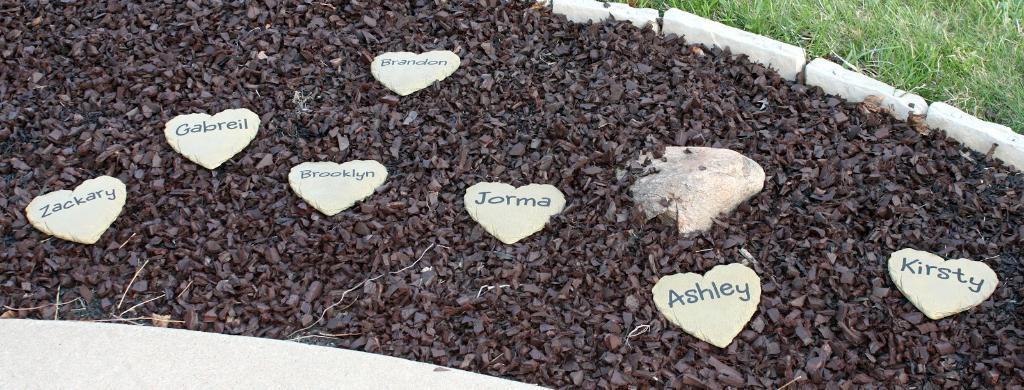What type of vegetation is present in the image? There is grass in the image. What other objects can be seen in the image besides the grass? There are stones and heart-shaped objects with text in the image. What discovery was made by the group of giants in the image? There are no giants or any discovery mentioned in the image; it only contains grass, stones, and heart-shaped objects with text. 